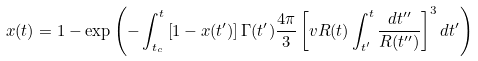Convert formula to latex. <formula><loc_0><loc_0><loc_500><loc_500>x ( t ) = 1 - \exp \left ( - \int _ { t _ { c } } ^ { t } \left [ 1 - x ( t ^ { \prime } ) \right ] \Gamma ( t ^ { \prime } ) \frac { 4 \pi } { 3 } \left [ v R ( t ) \int _ { t ^ { \prime } } ^ { t } \frac { d t ^ { \prime \prime } } { R ( t ^ { \prime \prime } ) } \right ] ^ { 3 } d t ^ { \prime } \right )</formula> 